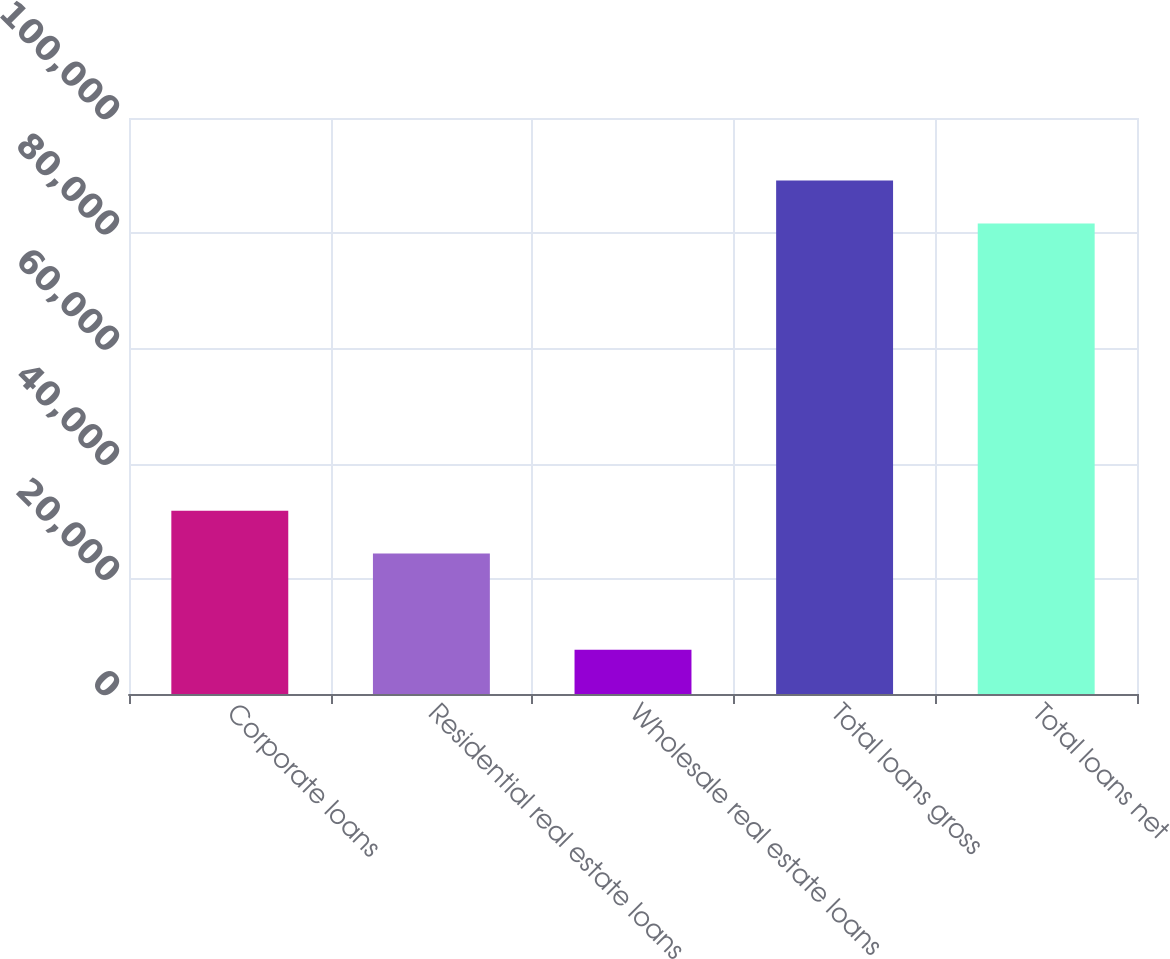<chart> <loc_0><loc_0><loc_500><loc_500><bar_chart><fcel>Corporate loans<fcel>Residential real estate loans<fcel>Wholesale real estate loans<fcel>Total loans gross<fcel>Total loans net<nl><fcel>31812.6<fcel>24385<fcel>7702<fcel>89131.6<fcel>81704<nl></chart> 